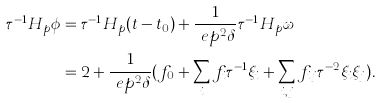Convert formula to latex. <formula><loc_0><loc_0><loc_500><loc_500>\tau ^ { - 1 } H _ { p } \phi & = \tau ^ { - 1 } H _ { p } ( t - t _ { 0 } ) + \frac { 1 } { \ e p ^ { 2 } \delta } \tau ^ { - 1 } H _ { p } \omega \\ & = 2 + \frac { 1 } { \ e p ^ { 2 } \delta } ( f _ { 0 } + \sum _ { i } f _ { i } \tau ^ { - 1 } \xi _ { i } + \sum _ { i , j } f _ { i j } \tau ^ { - 2 } \xi _ { i } \xi _ { j } ) .</formula> 